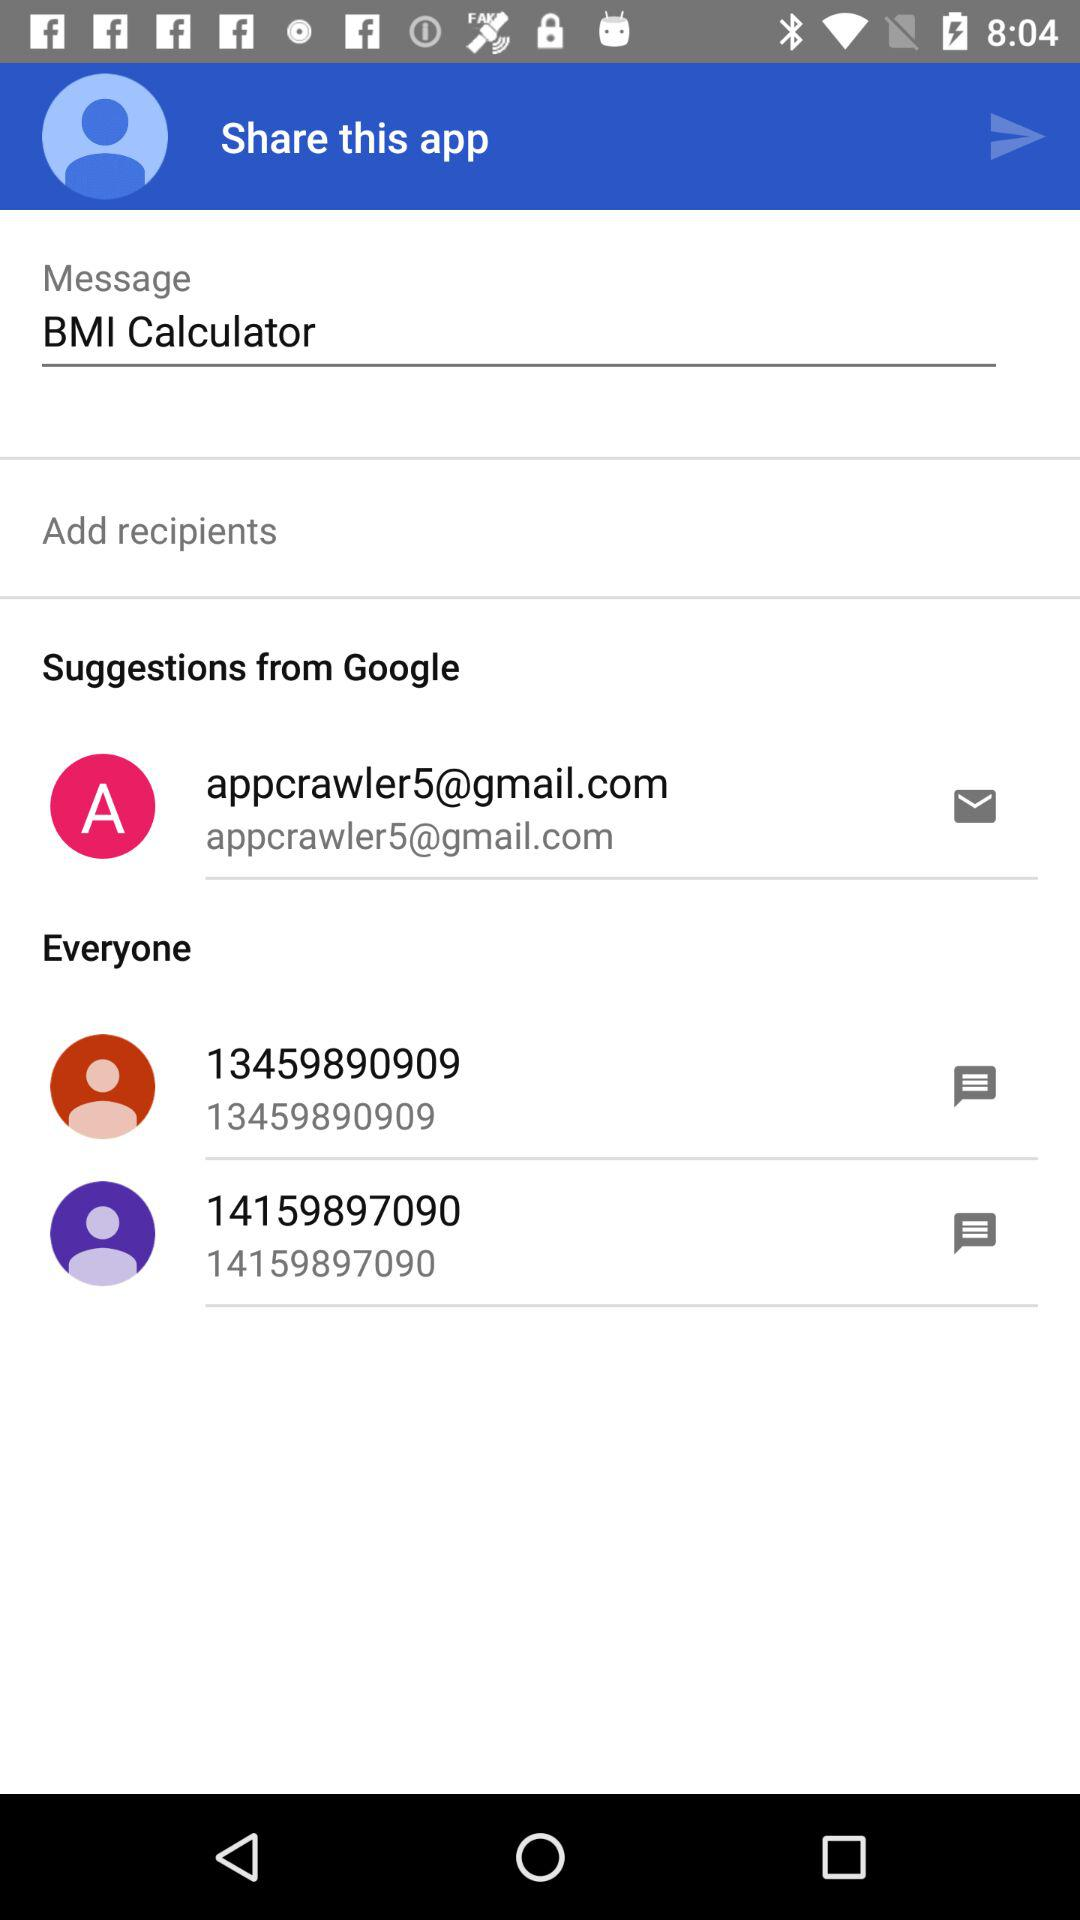From where did we get suggestions? You got suggestions from "Google". 